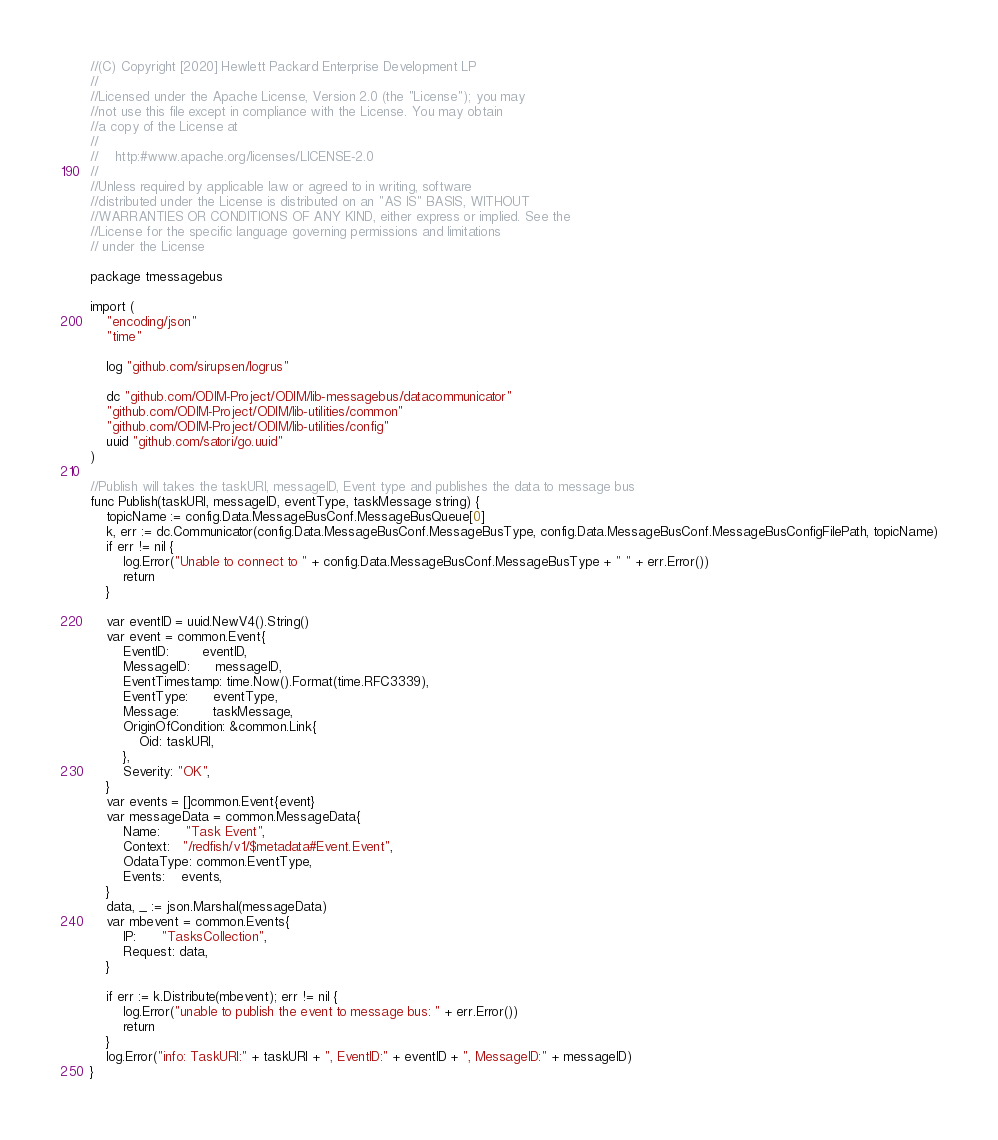Convert code to text. <code><loc_0><loc_0><loc_500><loc_500><_Go_>//(C) Copyright [2020] Hewlett Packard Enterprise Development LP
//
//Licensed under the Apache License, Version 2.0 (the "License"); you may
//not use this file except in compliance with the License. You may obtain
//a copy of the License at
//
//    http:#www.apache.org/licenses/LICENSE-2.0
//
//Unless required by applicable law or agreed to in writing, software
//distributed under the License is distributed on an "AS IS" BASIS, WITHOUT
//WARRANTIES OR CONDITIONS OF ANY KIND, either express or implied. See the
//License for the specific language governing permissions and limitations
// under the License

package tmessagebus

import (
	"encoding/json"
	"time"

	log "github.com/sirupsen/logrus"

	dc "github.com/ODIM-Project/ODIM/lib-messagebus/datacommunicator"
	"github.com/ODIM-Project/ODIM/lib-utilities/common"
	"github.com/ODIM-Project/ODIM/lib-utilities/config"
	uuid "github.com/satori/go.uuid"
)

//Publish will takes the taskURI, messageID, Event type and publishes the data to message bus
func Publish(taskURI, messageID, eventType, taskMessage string) {
	topicName := config.Data.MessageBusConf.MessageBusQueue[0]
	k, err := dc.Communicator(config.Data.MessageBusConf.MessageBusType, config.Data.MessageBusConf.MessageBusConfigFilePath, topicName)
	if err != nil {
		log.Error("Unable to connect to " + config.Data.MessageBusConf.MessageBusType + " " + err.Error())
		return
	}

	var eventID = uuid.NewV4().String()
	var event = common.Event{
		EventID:        eventID,
		MessageID:      messageID,
		EventTimestamp: time.Now().Format(time.RFC3339),
		EventType:      eventType,
		Message:        taskMessage,
		OriginOfCondition: &common.Link{
			Oid: taskURI,
		},
		Severity: "OK",
	}
	var events = []common.Event{event}
	var messageData = common.MessageData{
		Name:      "Task Event",
		Context:   "/redfish/v1/$metadata#Event.Event",
		OdataType: common.EventType,
		Events:    events,
	}
	data, _ := json.Marshal(messageData)
	var mbevent = common.Events{
		IP:      "TasksCollection",
		Request: data,
	}

	if err := k.Distribute(mbevent); err != nil {
		log.Error("unable to publish the event to message bus: " + err.Error())
		return
	}
	log.Error("info: TaskURI:" + taskURI + ", EventID:" + eventID + ", MessageID:" + messageID)
}
</code> 